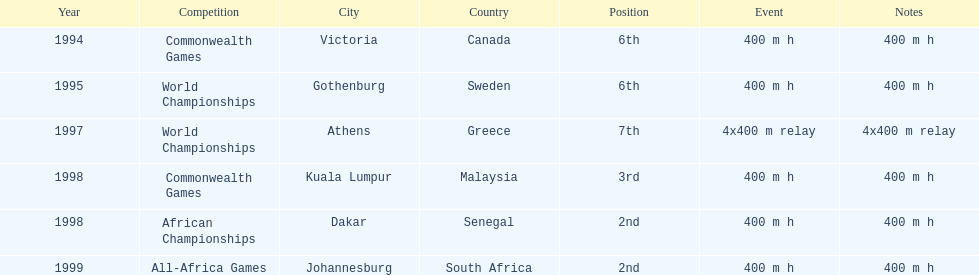Other than 1999, what year did ken harnden win second place? 1998. 